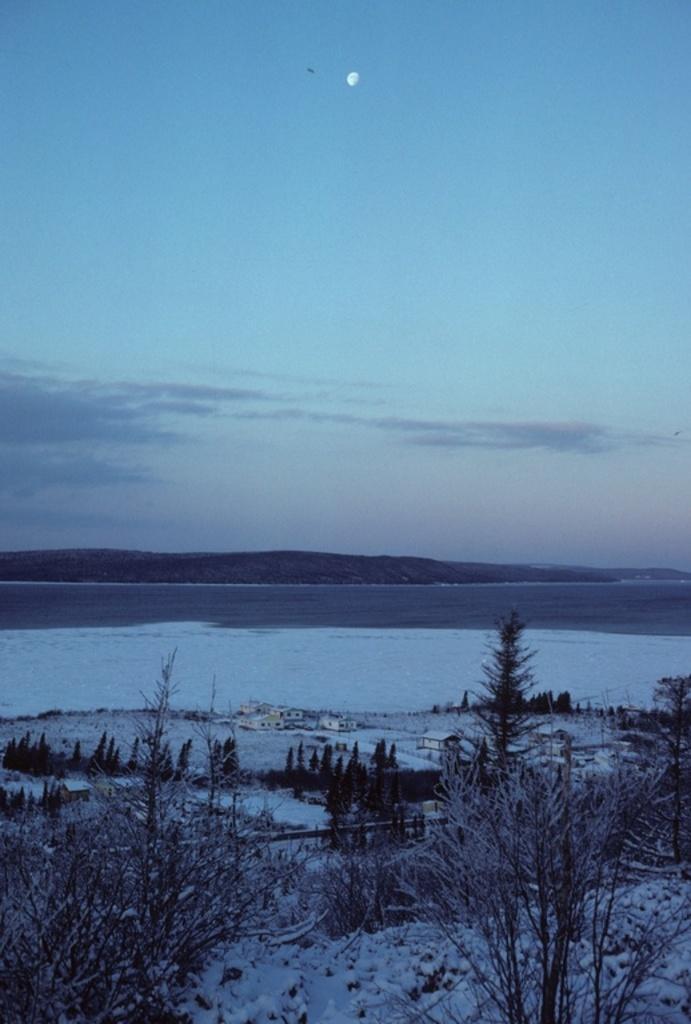Could you give a brief overview of what you see in this image? This image consists of many plants. At the bottom, there is snow. In the middle, we can see the water. At the top, there is sky. 